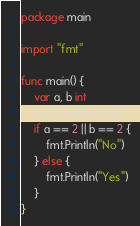<code> <loc_0><loc_0><loc_500><loc_500><_Go_>package main

import "fmt"

func main() {
	var a, b int
	fmt.Scan(&a, &b)
	if a == 2 || b == 2 {
		fmt.Println("No")
	} else {
		fmt.Println("Yes")
	}
}
</code> 